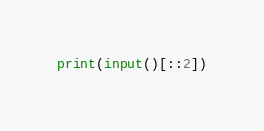<code> <loc_0><loc_0><loc_500><loc_500><_Python_>print(input()[::2])</code> 